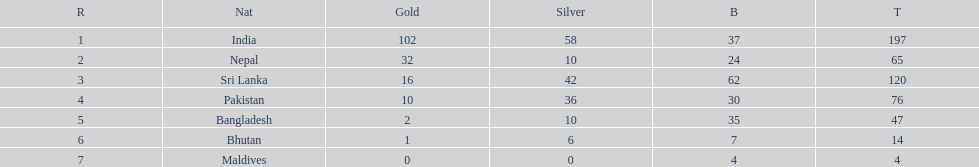Who has won the most bronze medals? Sri Lanka. 